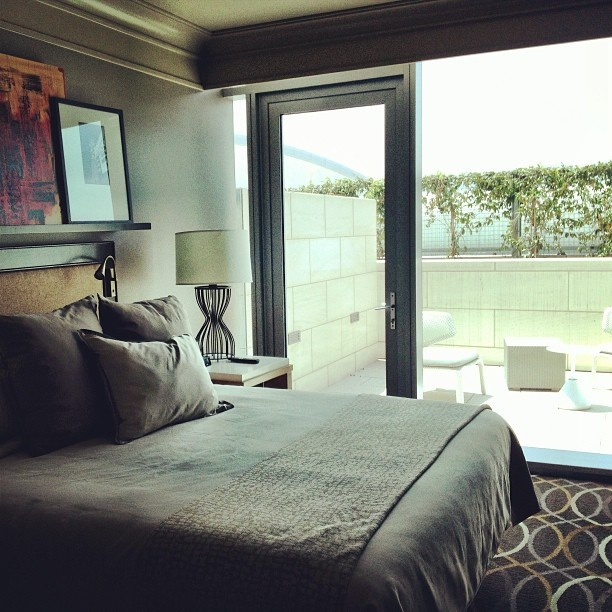Describe the objects in this image and their specific colors. I can see bed in black, darkgray, and gray tones, chair in black, ivory, beige, darkgray, and lightgray tones, chair in beige, black, and ivory tones, and remote in black, gray, darkgray, and lightgray tones in this image. 